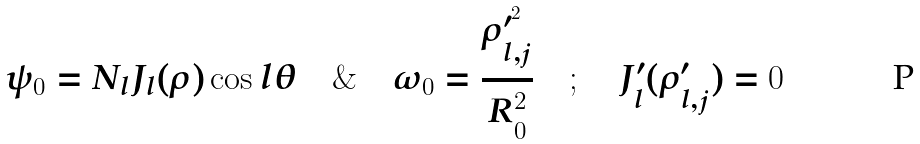<formula> <loc_0><loc_0><loc_500><loc_500>\psi _ { 0 } = N _ { l } J _ { l } ( \rho ) \cos l \theta \quad \& \quad \omega _ { 0 } = \frac { \rho ^ { \prime ^ { 2 } } _ { l , j } } { R _ { 0 } ^ { 2 } } \quad ; \quad J _ { l } ^ { \prime } ( \rho ^ { \prime } _ { l , j } ) = 0</formula> 